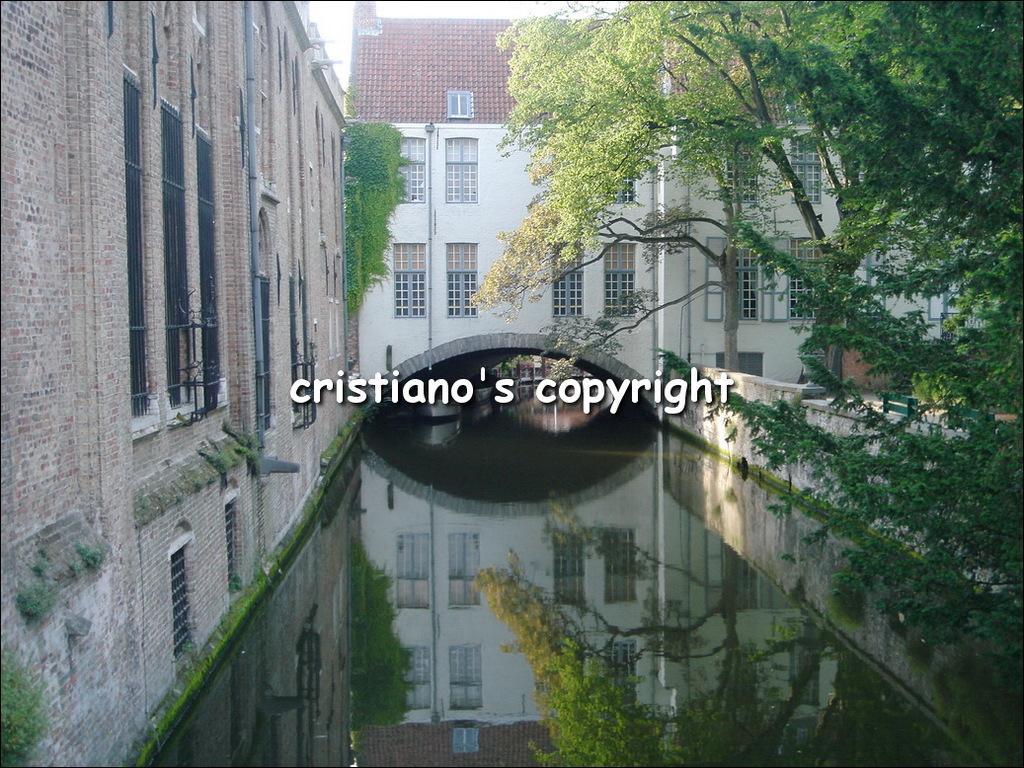Please provide a concise description of this image. There is water at the center. There are trees at the right. There are buildings. There is a brick building at the left which has windows and a pipe. 